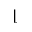Convert formula to latex. <formula><loc_0><loc_0><loc_500><loc_500>\lfloor</formula> 